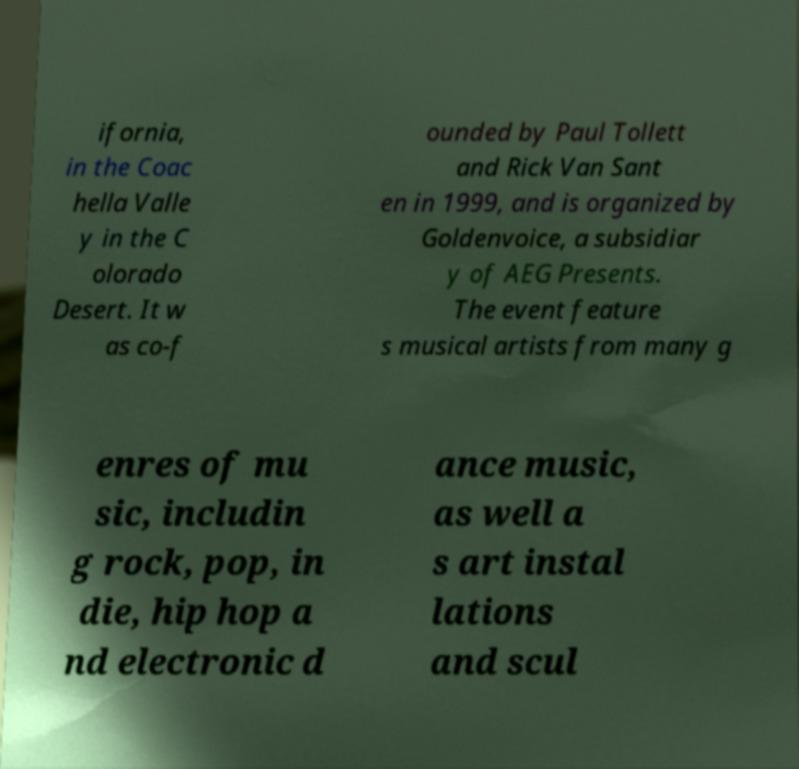I need the written content from this picture converted into text. Can you do that? ifornia, in the Coac hella Valle y in the C olorado Desert. It w as co-f ounded by Paul Tollett and Rick Van Sant en in 1999, and is organized by Goldenvoice, a subsidiar y of AEG Presents. The event feature s musical artists from many g enres of mu sic, includin g rock, pop, in die, hip hop a nd electronic d ance music, as well a s art instal lations and scul 